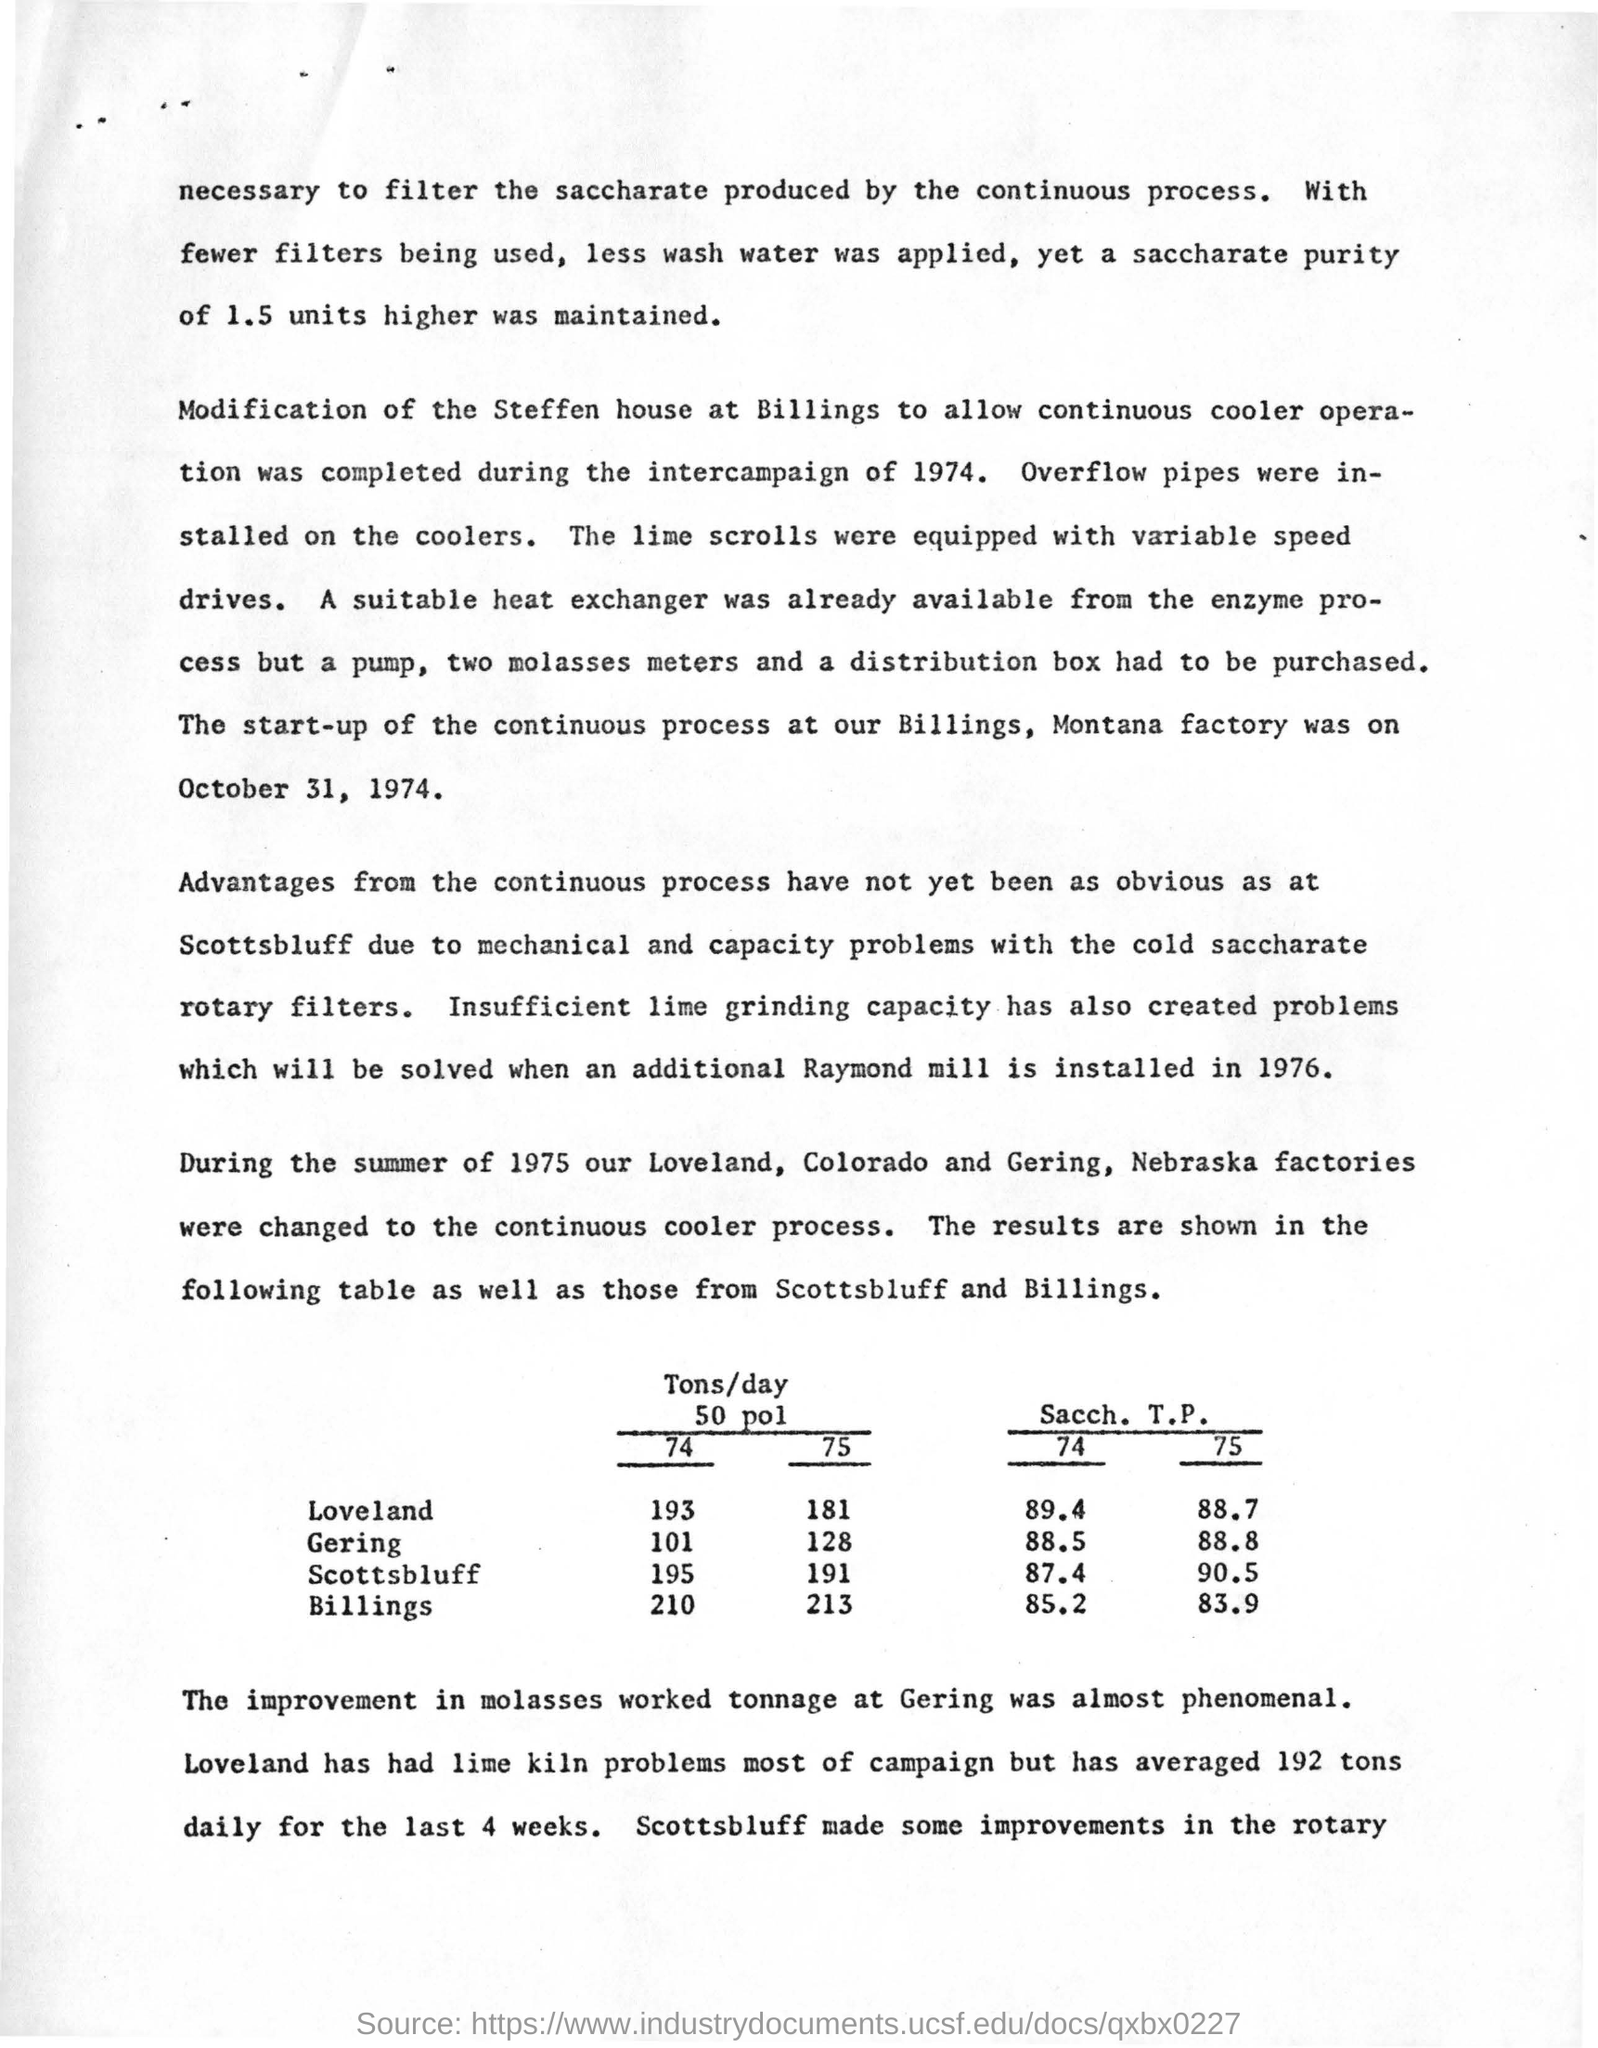Draw attention to some important aspects in this diagram. In the summer of 1975, the continuous cooler process was implemented at the Loveland, Colorado and Gering, Nebraska factories. At Gering, for 74 how many tons of 50 pounds of feed per day? The Raymond mill was installed in the year 1976. The start-up of the continuous process at the Billings, Montana factory occurred on October 31, 1974. The improvement in molasses tonnage at Gering How was almost phenomenal. 